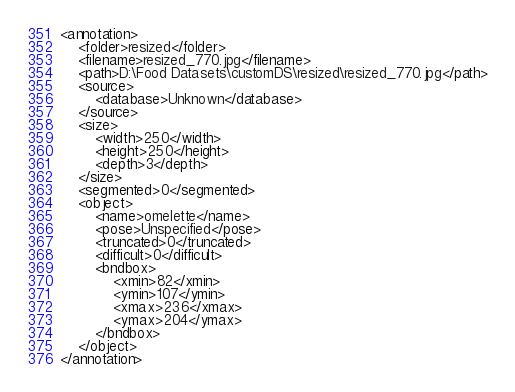<code> <loc_0><loc_0><loc_500><loc_500><_XML_><annotation>
	<folder>resized</folder>
	<filename>resized_770.jpg</filename>
	<path>D:\Food Datasets\customDS\resized\resized_770.jpg</path>
	<source>
		<database>Unknown</database>
	</source>
	<size>
		<width>250</width>
		<height>250</height>
		<depth>3</depth>
	</size>
	<segmented>0</segmented>
	<object>
		<name>omelette</name>
		<pose>Unspecified</pose>
		<truncated>0</truncated>
		<difficult>0</difficult>
		<bndbox>
			<xmin>82</xmin>
			<ymin>107</ymin>
			<xmax>236</xmax>
			<ymax>204</ymax>
		</bndbox>
	</object>
</annotation>
</code> 